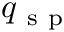<formula> <loc_0><loc_0><loc_500><loc_500>q _ { s p }</formula> 